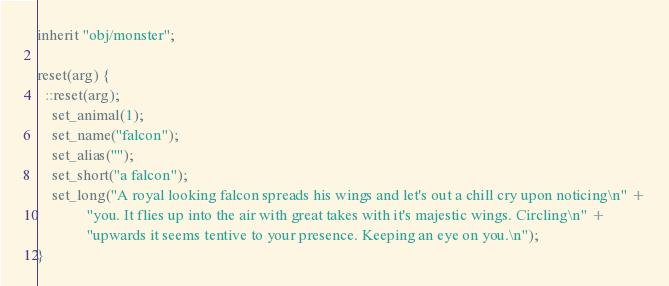<code> <loc_0><loc_0><loc_500><loc_500><_C_>inherit "obj/monster";

reset(arg) {
  ::reset(arg);
    set_animal(1);
    set_name("falcon");
    set_alias("");
    set_short("a falcon");
    set_long("A royal looking falcon spreads his wings and let's out a chill cry upon noticing\n" +
             "you. It flies up into the air with great takes with it's majestic wings. Circling\n" +
             "upwards it seems tentive to your presence. Keeping an eye on you.\n");
}
</code> 